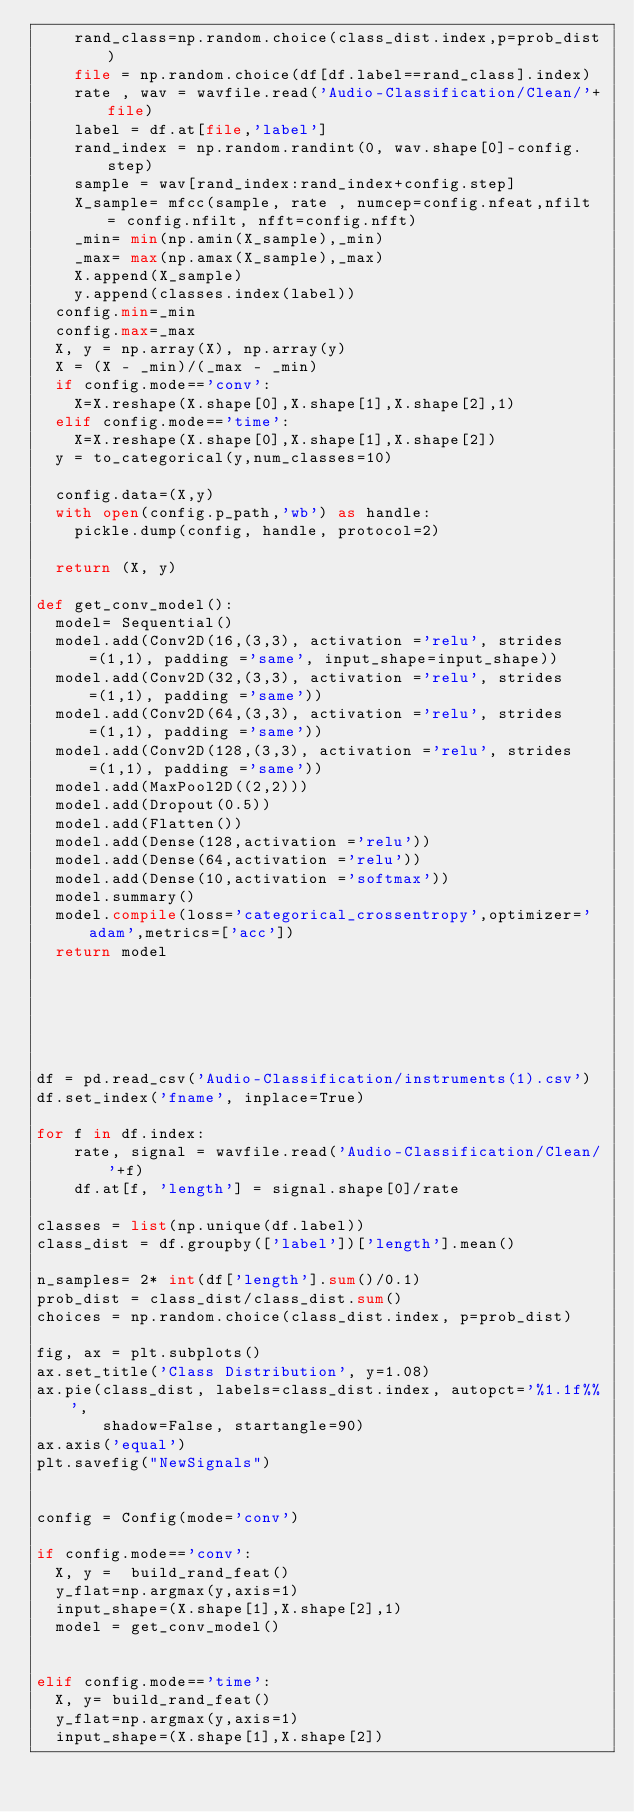Convert code to text. <code><loc_0><loc_0><loc_500><loc_500><_Python_>    rand_class=np.random.choice(class_dist.index,p=prob_dist)
    file = np.random.choice(df[df.label==rand_class].index)
    rate , wav = wavfile.read('Audio-Classification/Clean/'+file)
    label = df.at[file,'label']
    rand_index = np.random.randint(0, wav.shape[0]-config.step)
    sample = wav[rand_index:rand_index+config.step]
    X_sample= mfcc(sample, rate , numcep=config.nfeat,nfilt = config.nfilt, nfft=config.nfft)
    _min= min(np.amin(X_sample),_min)
    _max= max(np.amax(X_sample),_max)
    X.append(X_sample)
    y.append(classes.index(label))
  config.min=_min
  config.max=_max
  X, y = np.array(X), np.array(y)
  X = (X - _min)/(_max - _min)
  if config.mode=='conv':
    X=X.reshape(X.shape[0],X.shape[1],X.shape[2],1)
  elif config.mode=='time':
    X=X.reshape(X.shape[0],X.shape[1],X.shape[2])
  y = to_categorical(y,num_classes=10)

  config.data=(X,y)
  with open(config.p_path,'wb') as handle:
    pickle.dump(config, handle, protocol=2)

  return (X, y)

def get_conv_model():
  model= Sequential()
  model.add(Conv2D(16,(3,3), activation ='relu', strides=(1,1), padding ='same', input_shape=input_shape))
  model.add(Conv2D(32,(3,3), activation ='relu', strides=(1,1), padding ='same'))
  model.add(Conv2D(64,(3,3), activation ='relu', strides=(1,1), padding ='same'))
  model.add(Conv2D(128,(3,3), activation ='relu', strides=(1,1), padding ='same'))
  model.add(MaxPool2D((2,2)))
  model.add(Dropout(0.5))
  model.add(Flatten())
  model.add(Dense(128,activation ='relu'))
  model.add(Dense(64,activation ='relu'))
  model.add(Dense(10,activation ='softmax'))
  model.summary()
  model.compile(loss='categorical_crossentropy',optimizer='adam',metrics=['acc'])
  return model






df = pd.read_csv('Audio-Classification/instruments(1).csv')
df.set_index('fname', inplace=True)

for f in df.index:
    rate, signal = wavfile.read('Audio-Classification/Clean/'+f)
    df.at[f, 'length'] = signal.shape[0]/rate

classes = list(np.unique(df.label))
class_dist = df.groupby(['label'])['length'].mean()

n_samples= 2* int(df['length'].sum()/0.1)
prob_dist = class_dist/class_dist.sum()
choices = np.random.choice(class_dist.index, p=prob_dist)

fig, ax = plt.subplots()
ax.set_title('Class Distribution', y=1.08)
ax.pie(class_dist, labels=class_dist.index, autopct='%1.1f%%',
       shadow=False, startangle=90)
ax.axis('equal')
plt.savefig("NewSignals")


config = Config(mode='conv')

if config.mode=='conv':
  X, y =  build_rand_feat()
  y_flat=np.argmax(y,axis=1)
  input_shape=(X.shape[1],X.shape[2],1)
  model = get_conv_model()


elif config.mode=='time':
  X, y= build_rand_feat()
  y_flat=np.argmax(y,axis=1)
  input_shape=(X.shape[1],X.shape[2])</code> 